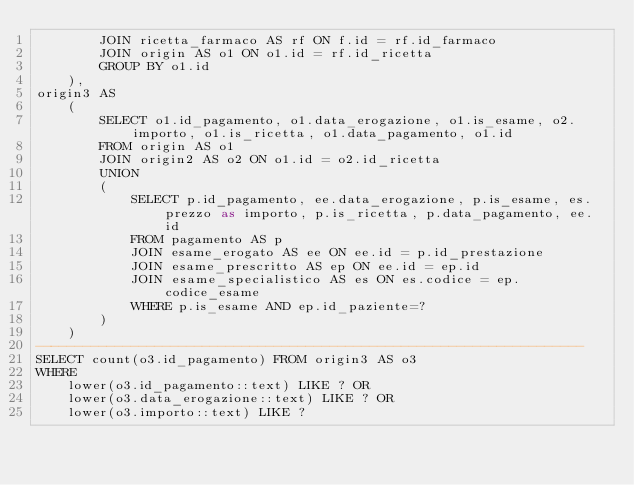<code> <loc_0><loc_0><loc_500><loc_500><_SQL_>        JOIN ricetta_farmaco AS rf ON f.id = rf.id_farmaco
        JOIN origin AS o1 ON o1.id = rf.id_ricetta
        GROUP BY o1.id
    ),
origin3 AS
    (
        SELECT o1.id_pagamento, o1.data_erogazione, o1.is_esame, o2.importo, o1.is_ricetta, o1.data_pagamento, o1.id
        FROM origin AS o1
        JOIN origin2 AS o2 ON o1.id = o2.id_ricetta
        UNION
        (
            SELECT p.id_pagamento, ee.data_erogazione, p.is_esame, es.prezzo as importo, p.is_ricetta, p.data_pagamento, ee.id
            FROM pagamento AS p
            JOIN esame_erogato AS ee ON ee.id = p.id_prestazione
            JOIN esame_prescritto AS ep ON ee.id = ep.id
            JOIN esame_specialistico AS es ON es.codice = ep.codice_esame
            WHERE p.is_esame AND ep.id_paziente=?
        )
    )
---------------------------------------------------------------------
SELECT count(o3.id_pagamento) FROM origin3 AS o3
WHERE
    lower(o3.id_pagamento::text) LIKE ? OR
    lower(o3.data_erogazione::text) LIKE ? OR
    lower(o3.importo::text) LIKE ?</code> 